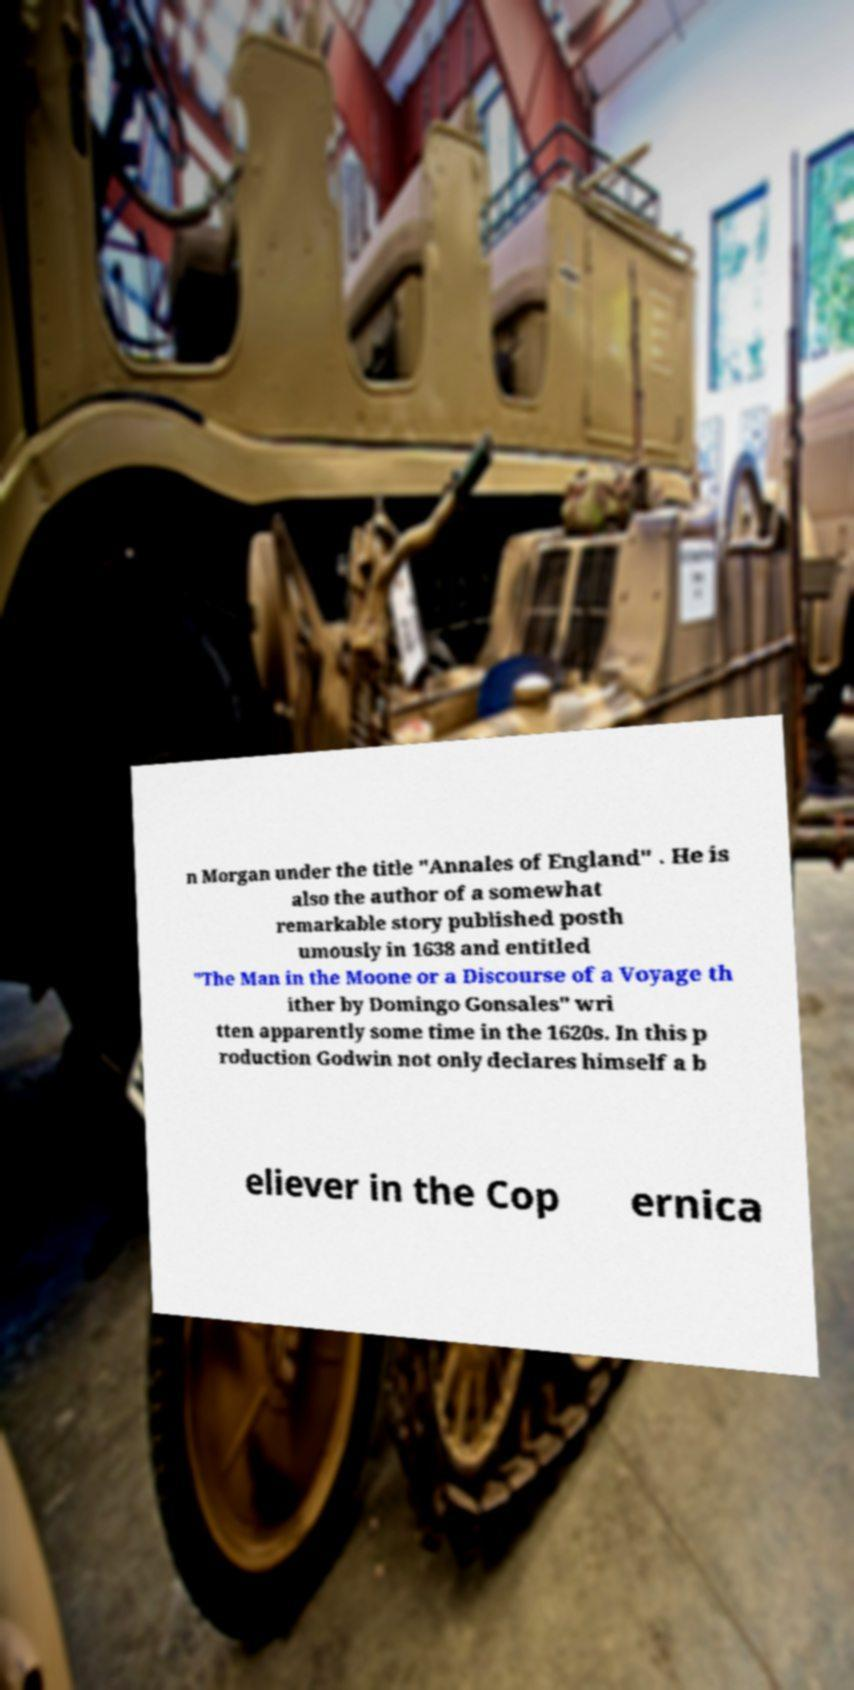Please identify and transcribe the text found in this image. n Morgan under the title "Annales of England" . He is also the author of a somewhat remarkable story published posth umously in 1638 and entitled "The Man in the Moone or a Discourse of a Voyage th ither by Domingo Gonsales" wri tten apparently some time in the 1620s. In this p roduction Godwin not only declares himself a b eliever in the Cop ernica 